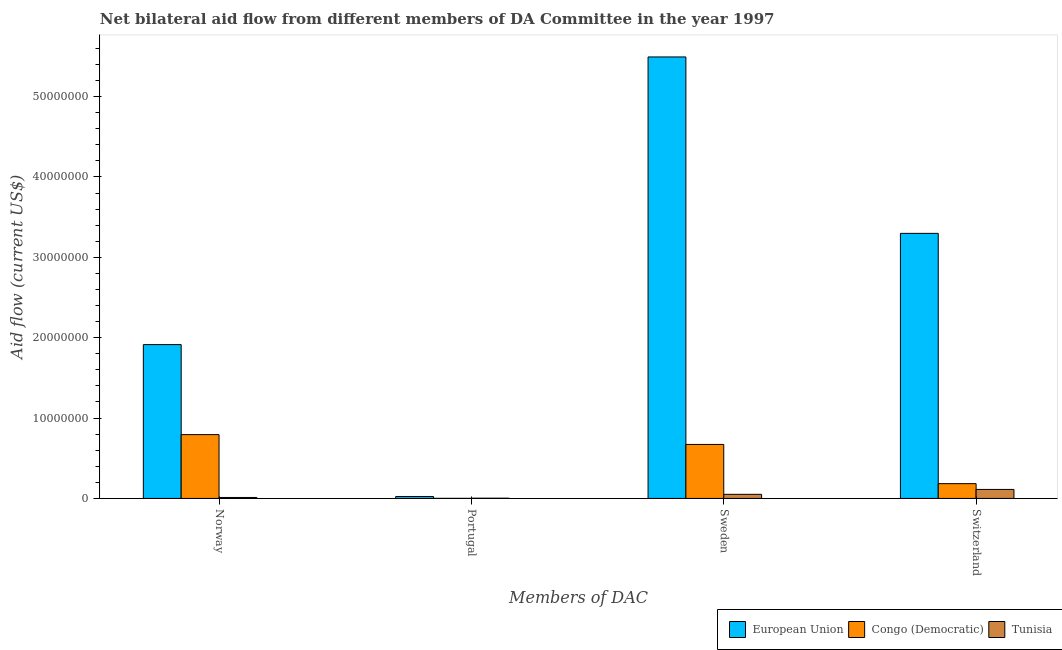What is the label of the 4th group of bars from the left?
Provide a short and direct response. Switzerland. What is the amount of aid given by sweden in Congo (Democratic)?
Your answer should be compact. 6.72e+06. Across all countries, what is the maximum amount of aid given by sweden?
Your answer should be compact. 5.49e+07. Across all countries, what is the minimum amount of aid given by norway?
Provide a succinct answer. 1.20e+05. In which country was the amount of aid given by norway maximum?
Keep it short and to the point. European Union. In which country was the amount of aid given by sweden minimum?
Provide a short and direct response. Tunisia. What is the total amount of aid given by norway in the graph?
Give a very brief answer. 2.72e+07. What is the difference between the amount of aid given by switzerland in Tunisia and that in European Union?
Your answer should be very brief. -3.19e+07. What is the difference between the amount of aid given by norway in European Union and the amount of aid given by switzerland in Tunisia?
Your response must be concise. 1.80e+07. What is the average amount of aid given by sweden per country?
Offer a very short reply. 2.07e+07. What is the difference between the amount of aid given by sweden and amount of aid given by portugal in Tunisia?
Give a very brief answer. 4.80e+05. In how many countries, is the amount of aid given by norway greater than 24000000 US$?
Offer a very short reply. 0. What is the ratio of the amount of aid given by norway in Tunisia to that in European Union?
Give a very brief answer. 0.01. What is the difference between the highest and the second highest amount of aid given by norway?
Your response must be concise. 1.12e+07. What is the difference between the highest and the lowest amount of aid given by norway?
Keep it short and to the point. 1.90e+07. In how many countries, is the amount of aid given by sweden greater than the average amount of aid given by sweden taken over all countries?
Provide a short and direct response. 1. Is the sum of the amount of aid given by switzerland in Congo (Democratic) and Tunisia greater than the maximum amount of aid given by portugal across all countries?
Give a very brief answer. Yes. Is it the case that in every country, the sum of the amount of aid given by norway and amount of aid given by portugal is greater than the sum of amount of aid given by switzerland and amount of aid given by sweden?
Your answer should be compact. No. What does the 3rd bar from the left in Sweden represents?
Provide a short and direct response. Tunisia. What does the 1st bar from the right in Portugal represents?
Offer a very short reply. Tunisia. How many bars are there?
Ensure brevity in your answer.  12. Are all the bars in the graph horizontal?
Provide a short and direct response. No. How many countries are there in the graph?
Give a very brief answer. 3. What is the difference between two consecutive major ticks on the Y-axis?
Provide a succinct answer. 1.00e+07. Does the graph contain any zero values?
Offer a very short reply. No. Does the graph contain grids?
Offer a terse response. No. How are the legend labels stacked?
Offer a terse response. Horizontal. What is the title of the graph?
Offer a very short reply. Net bilateral aid flow from different members of DA Committee in the year 1997. What is the label or title of the X-axis?
Give a very brief answer. Members of DAC. What is the label or title of the Y-axis?
Your answer should be compact. Aid flow (current US$). What is the Aid flow (current US$) of European Union in Norway?
Make the answer very short. 1.91e+07. What is the Aid flow (current US$) of Congo (Democratic) in Norway?
Your answer should be very brief. 7.94e+06. What is the Aid flow (current US$) in Tunisia in Norway?
Your response must be concise. 1.20e+05. What is the Aid flow (current US$) of Tunisia in Portugal?
Your answer should be very brief. 3.00e+04. What is the Aid flow (current US$) of European Union in Sweden?
Your response must be concise. 5.49e+07. What is the Aid flow (current US$) of Congo (Democratic) in Sweden?
Your response must be concise. 6.72e+06. What is the Aid flow (current US$) in Tunisia in Sweden?
Offer a very short reply. 5.10e+05. What is the Aid flow (current US$) in European Union in Switzerland?
Ensure brevity in your answer.  3.30e+07. What is the Aid flow (current US$) in Congo (Democratic) in Switzerland?
Your answer should be very brief. 1.84e+06. What is the Aid flow (current US$) in Tunisia in Switzerland?
Provide a succinct answer. 1.12e+06. Across all Members of DAC, what is the maximum Aid flow (current US$) of European Union?
Make the answer very short. 5.49e+07. Across all Members of DAC, what is the maximum Aid flow (current US$) in Congo (Democratic)?
Your answer should be compact. 7.94e+06. Across all Members of DAC, what is the maximum Aid flow (current US$) in Tunisia?
Provide a short and direct response. 1.12e+06. Across all Members of DAC, what is the minimum Aid flow (current US$) in European Union?
Provide a short and direct response. 2.40e+05. What is the total Aid flow (current US$) of European Union in the graph?
Make the answer very short. 1.07e+08. What is the total Aid flow (current US$) in Congo (Democratic) in the graph?
Ensure brevity in your answer.  1.65e+07. What is the total Aid flow (current US$) in Tunisia in the graph?
Give a very brief answer. 1.78e+06. What is the difference between the Aid flow (current US$) of European Union in Norway and that in Portugal?
Keep it short and to the point. 1.89e+07. What is the difference between the Aid flow (current US$) in Congo (Democratic) in Norway and that in Portugal?
Your answer should be compact. 7.93e+06. What is the difference between the Aid flow (current US$) in Tunisia in Norway and that in Portugal?
Offer a very short reply. 9.00e+04. What is the difference between the Aid flow (current US$) of European Union in Norway and that in Sweden?
Offer a very short reply. -3.58e+07. What is the difference between the Aid flow (current US$) of Congo (Democratic) in Norway and that in Sweden?
Offer a very short reply. 1.22e+06. What is the difference between the Aid flow (current US$) in Tunisia in Norway and that in Sweden?
Provide a short and direct response. -3.90e+05. What is the difference between the Aid flow (current US$) in European Union in Norway and that in Switzerland?
Offer a terse response. -1.38e+07. What is the difference between the Aid flow (current US$) of Congo (Democratic) in Norway and that in Switzerland?
Offer a very short reply. 6.10e+06. What is the difference between the Aid flow (current US$) of European Union in Portugal and that in Sweden?
Offer a very short reply. -5.47e+07. What is the difference between the Aid flow (current US$) of Congo (Democratic) in Portugal and that in Sweden?
Your response must be concise. -6.71e+06. What is the difference between the Aid flow (current US$) in Tunisia in Portugal and that in Sweden?
Offer a terse response. -4.80e+05. What is the difference between the Aid flow (current US$) in European Union in Portugal and that in Switzerland?
Your response must be concise. -3.27e+07. What is the difference between the Aid flow (current US$) of Congo (Democratic) in Portugal and that in Switzerland?
Provide a succinct answer. -1.83e+06. What is the difference between the Aid flow (current US$) of Tunisia in Portugal and that in Switzerland?
Your answer should be very brief. -1.09e+06. What is the difference between the Aid flow (current US$) in European Union in Sweden and that in Switzerland?
Give a very brief answer. 2.20e+07. What is the difference between the Aid flow (current US$) in Congo (Democratic) in Sweden and that in Switzerland?
Your response must be concise. 4.88e+06. What is the difference between the Aid flow (current US$) in Tunisia in Sweden and that in Switzerland?
Provide a short and direct response. -6.10e+05. What is the difference between the Aid flow (current US$) of European Union in Norway and the Aid flow (current US$) of Congo (Democratic) in Portugal?
Provide a short and direct response. 1.91e+07. What is the difference between the Aid flow (current US$) of European Union in Norway and the Aid flow (current US$) of Tunisia in Portugal?
Your response must be concise. 1.91e+07. What is the difference between the Aid flow (current US$) of Congo (Democratic) in Norway and the Aid flow (current US$) of Tunisia in Portugal?
Give a very brief answer. 7.91e+06. What is the difference between the Aid flow (current US$) of European Union in Norway and the Aid flow (current US$) of Congo (Democratic) in Sweden?
Provide a short and direct response. 1.24e+07. What is the difference between the Aid flow (current US$) in European Union in Norway and the Aid flow (current US$) in Tunisia in Sweden?
Provide a succinct answer. 1.86e+07. What is the difference between the Aid flow (current US$) of Congo (Democratic) in Norway and the Aid flow (current US$) of Tunisia in Sweden?
Provide a short and direct response. 7.43e+06. What is the difference between the Aid flow (current US$) of European Union in Norway and the Aid flow (current US$) of Congo (Democratic) in Switzerland?
Provide a succinct answer. 1.73e+07. What is the difference between the Aid flow (current US$) in European Union in Norway and the Aid flow (current US$) in Tunisia in Switzerland?
Make the answer very short. 1.80e+07. What is the difference between the Aid flow (current US$) in Congo (Democratic) in Norway and the Aid flow (current US$) in Tunisia in Switzerland?
Offer a very short reply. 6.82e+06. What is the difference between the Aid flow (current US$) of European Union in Portugal and the Aid flow (current US$) of Congo (Democratic) in Sweden?
Keep it short and to the point. -6.48e+06. What is the difference between the Aid flow (current US$) of European Union in Portugal and the Aid flow (current US$) of Tunisia in Sweden?
Offer a very short reply. -2.70e+05. What is the difference between the Aid flow (current US$) in Congo (Democratic) in Portugal and the Aid flow (current US$) in Tunisia in Sweden?
Give a very brief answer. -5.00e+05. What is the difference between the Aid flow (current US$) in European Union in Portugal and the Aid flow (current US$) in Congo (Democratic) in Switzerland?
Offer a terse response. -1.60e+06. What is the difference between the Aid flow (current US$) of European Union in Portugal and the Aid flow (current US$) of Tunisia in Switzerland?
Make the answer very short. -8.80e+05. What is the difference between the Aid flow (current US$) in Congo (Democratic) in Portugal and the Aid flow (current US$) in Tunisia in Switzerland?
Provide a succinct answer. -1.11e+06. What is the difference between the Aid flow (current US$) of European Union in Sweden and the Aid flow (current US$) of Congo (Democratic) in Switzerland?
Give a very brief answer. 5.31e+07. What is the difference between the Aid flow (current US$) in European Union in Sweden and the Aid flow (current US$) in Tunisia in Switzerland?
Your answer should be compact. 5.38e+07. What is the difference between the Aid flow (current US$) of Congo (Democratic) in Sweden and the Aid flow (current US$) of Tunisia in Switzerland?
Make the answer very short. 5.60e+06. What is the average Aid flow (current US$) of European Union per Members of DAC?
Offer a terse response. 2.68e+07. What is the average Aid flow (current US$) of Congo (Democratic) per Members of DAC?
Ensure brevity in your answer.  4.13e+06. What is the average Aid flow (current US$) in Tunisia per Members of DAC?
Your answer should be compact. 4.45e+05. What is the difference between the Aid flow (current US$) in European Union and Aid flow (current US$) in Congo (Democratic) in Norway?
Your response must be concise. 1.12e+07. What is the difference between the Aid flow (current US$) in European Union and Aid flow (current US$) in Tunisia in Norway?
Your response must be concise. 1.90e+07. What is the difference between the Aid flow (current US$) in Congo (Democratic) and Aid flow (current US$) in Tunisia in Norway?
Keep it short and to the point. 7.82e+06. What is the difference between the Aid flow (current US$) of Congo (Democratic) and Aid flow (current US$) of Tunisia in Portugal?
Your answer should be very brief. -2.00e+04. What is the difference between the Aid flow (current US$) in European Union and Aid flow (current US$) in Congo (Democratic) in Sweden?
Ensure brevity in your answer.  4.82e+07. What is the difference between the Aid flow (current US$) of European Union and Aid flow (current US$) of Tunisia in Sweden?
Make the answer very short. 5.44e+07. What is the difference between the Aid flow (current US$) of Congo (Democratic) and Aid flow (current US$) of Tunisia in Sweden?
Ensure brevity in your answer.  6.21e+06. What is the difference between the Aid flow (current US$) in European Union and Aid flow (current US$) in Congo (Democratic) in Switzerland?
Provide a short and direct response. 3.11e+07. What is the difference between the Aid flow (current US$) of European Union and Aid flow (current US$) of Tunisia in Switzerland?
Ensure brevity in your answer.  3.19e+07. What is the difference between the Aid flow (current US$) of Congo (Democratic) and Aid flow (current US$) of Tunisia in Switzerland?
Offer a very short reply. 7.20e+05. What is the ratio of the Aid flow (current US$) in European Union in Norway to that in Portugal?
Your answer should be compact. 79.75. What is the ratio of the Aid flow (current US$) of Congo (Democratic) in Norway to that in Portugal?
Offer a very short reply. 794. What is the ratio of the Aid flow (current US$) in Tunisia in Norway to that in Portugal?
Offer a terse response. 4. What is the ratio of the Aid flow (current US$) in European Union in Norway to that in Sweden?
Provide a succinct answer. 0.35. What is the ratio of the Aid flow (current US$) in Congo (Democratic) in Norway to that in Sweden?
Provide a short and direct response. 1.18. What is the ratio of the Aid flow (current US$) in Tunisia in Norway to that in Sweden?
Your answer should be compact. 0.24. What is the ratio of the Aid flow (current US$) in European Union in Norway to that in Switzerland?
Your answer should be compact. 0.58. What is the ratio of the Aid flow (current US$) of Congo (Democratic) in Norway to that in Switzerland?
Ensure brevity in your answer.  4.32. What is the ratio of the Aid flow (current US$) in Tunisia in Norway to that in Switzerland?
Ensure brevity in your answer.  0.11. What is the ratio of the Aid flow (current US$) in European Union in Portugal to that in Sweden?
Give a very brief answer. 0. What is the ratio of the Aid flow (current US$) in Congo (Democratic) in Portugal to that in Sweden?
Give a very brief answer. 0. What is the ratio of the Aid flow (current US$) in Tunisia in Portugal to that in Sweden?
Give a very brief answer. 0.06. What is the ratio of the Aid flow (current US$) in European Union in Portugal to that in Switzerland?
Your answer should be compact. 0.01. What is the ratio of the Aid flow (current US$) of Congo (Democratic) in Portugal to that in Switzerland?
Ensure brevity in your answer.  0.01. What is the ratio of the Aid flow (current US$) of Tunisia in Portugal to that in Switzerland?
Make the answer very short. 0.03. What is the ratio of the Aid flow (current US$) in European Union in Sweden to that in Switzerland?
Ensure brevity in your answer.  1.67. What is the ratio of the Aid flow (current US$) in Congo (Democratic) in Sweden to that in Switzerland?
Offer a terse response. 3.65. What is the ratio of the Aid flow (current US$) of Tunisia in Sweden to that in Switzerland?
Offer a terse response. 0.46. What is the difference between the highest and the second highest Aid flow (current US$) of European Union?
Offer a terse response. 2.20e+07. What is the difference between the highest and the second highest Aid flow (current US$) in Congo (Democratic)?
Your answer should be very brief. 1.22e+06. What is the difference between the highest and the lowest Aid flow (current US$) in European Union?
Your response must be concise. 5.47e+07. What is the difference between the highest and the lowest Aid flow (current US$) in Congo (Democratic)?
Ensure brevity in your answer.  7.93e+06. What is the difference between the highest and the lowest Aid flow (current US$) of Tunisia?
Your answer should be very brief. 1.09e+06. 